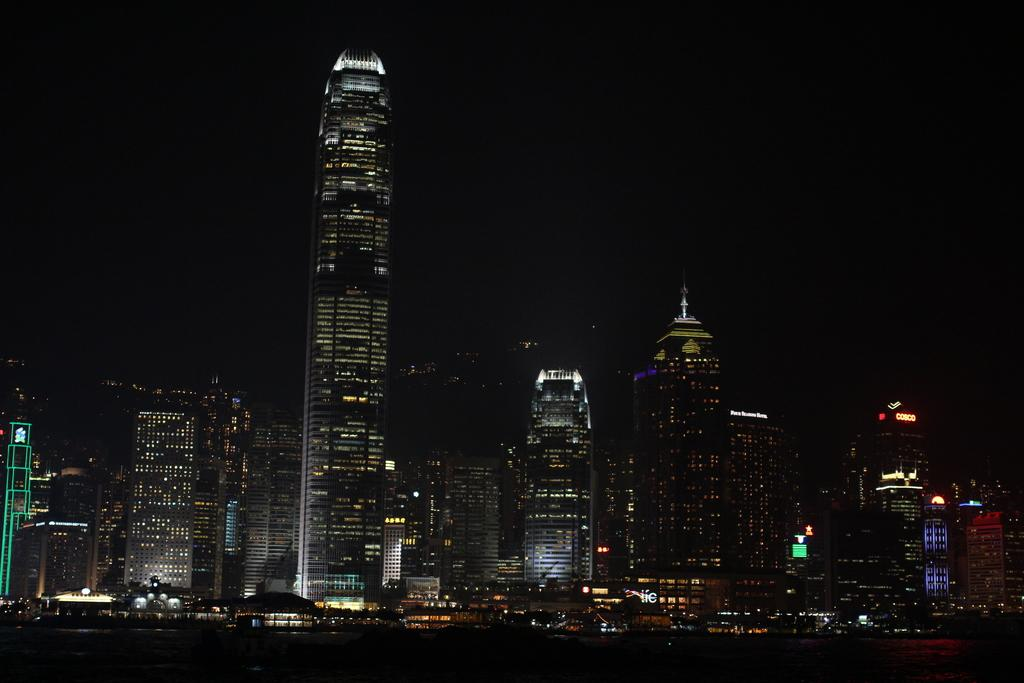What is the main subject of the image? The main subject of the image is many buildings. What feature do the buildings have? The buildings have lights. What color is the background of the image? The background of the image is black. What type of soup can be seen simmering on the wall in the image? There is no soup or wall present in the image; it features many buildings with lights against a black background. 